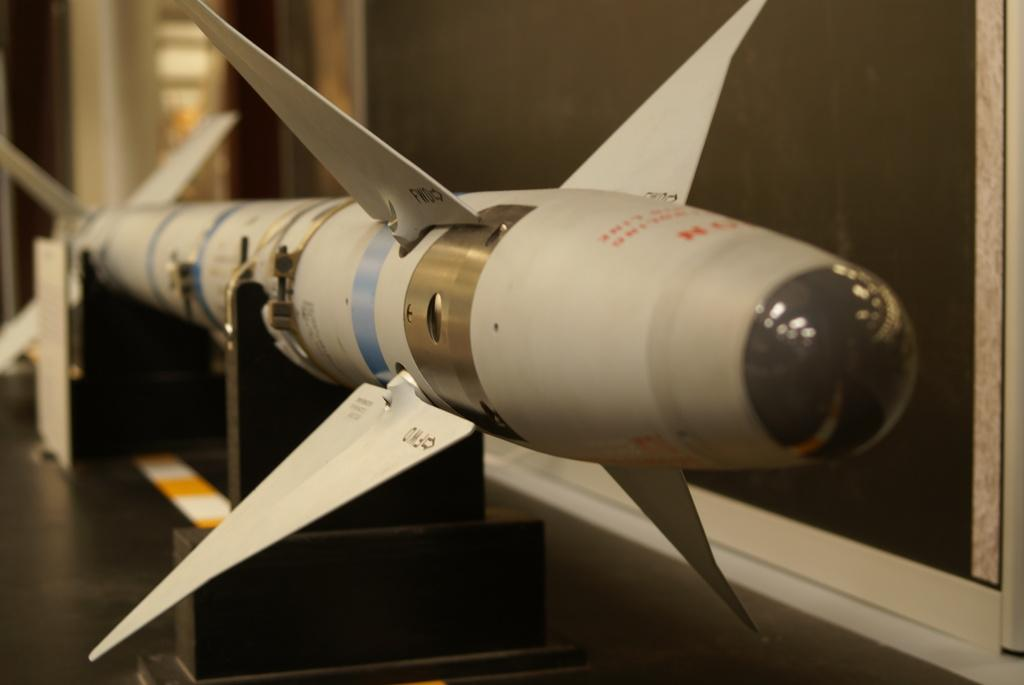What is the main subject of the image? The main subject of the image is a missile. How is the missile positioned in the image? The missile is placed on stands. What can be seen in the background of the image? There is a wall in the background of the image. What type of magic is being performed with the missile in the image? There is no magic or any indication of a magical performance in the image; it simply shows a missile on stands. What idea is being conveyed through the presence of the missile in the image? The image does not explicitly convey any specific idea or message; it simply depicts a missile on stands. 